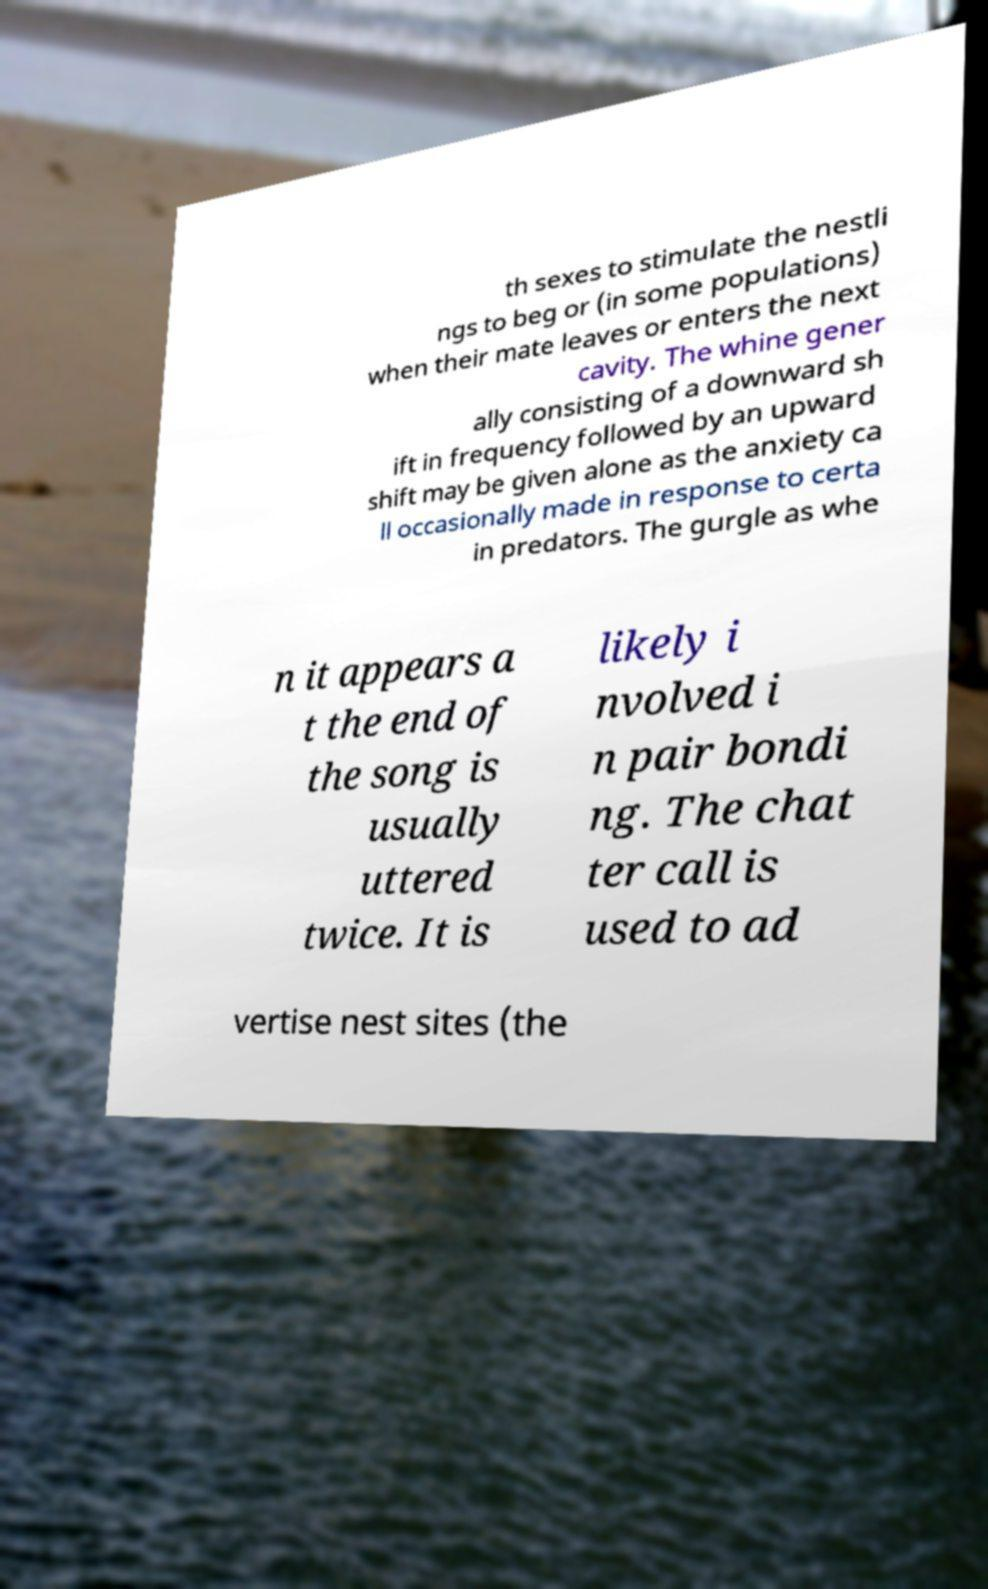There's text embedded in this image that I need extracted. Can you transcribe it verbatim? th sexes to stimulate the nestli ngs to beg or (in some populations) when their mate leaves or enters the next cavity. The whine gener ally consisting of a downward sh ift in frequency followed by an upward shift may be given alone as the anxiety ca ll occasionally made in response to certa in predators. The gurgle as whe n it appears a t the end of the song is usually uttered twice. It is likely i nvolved i n pair bondi ng. The chat ter call is used to ad vertise nest sites (the 